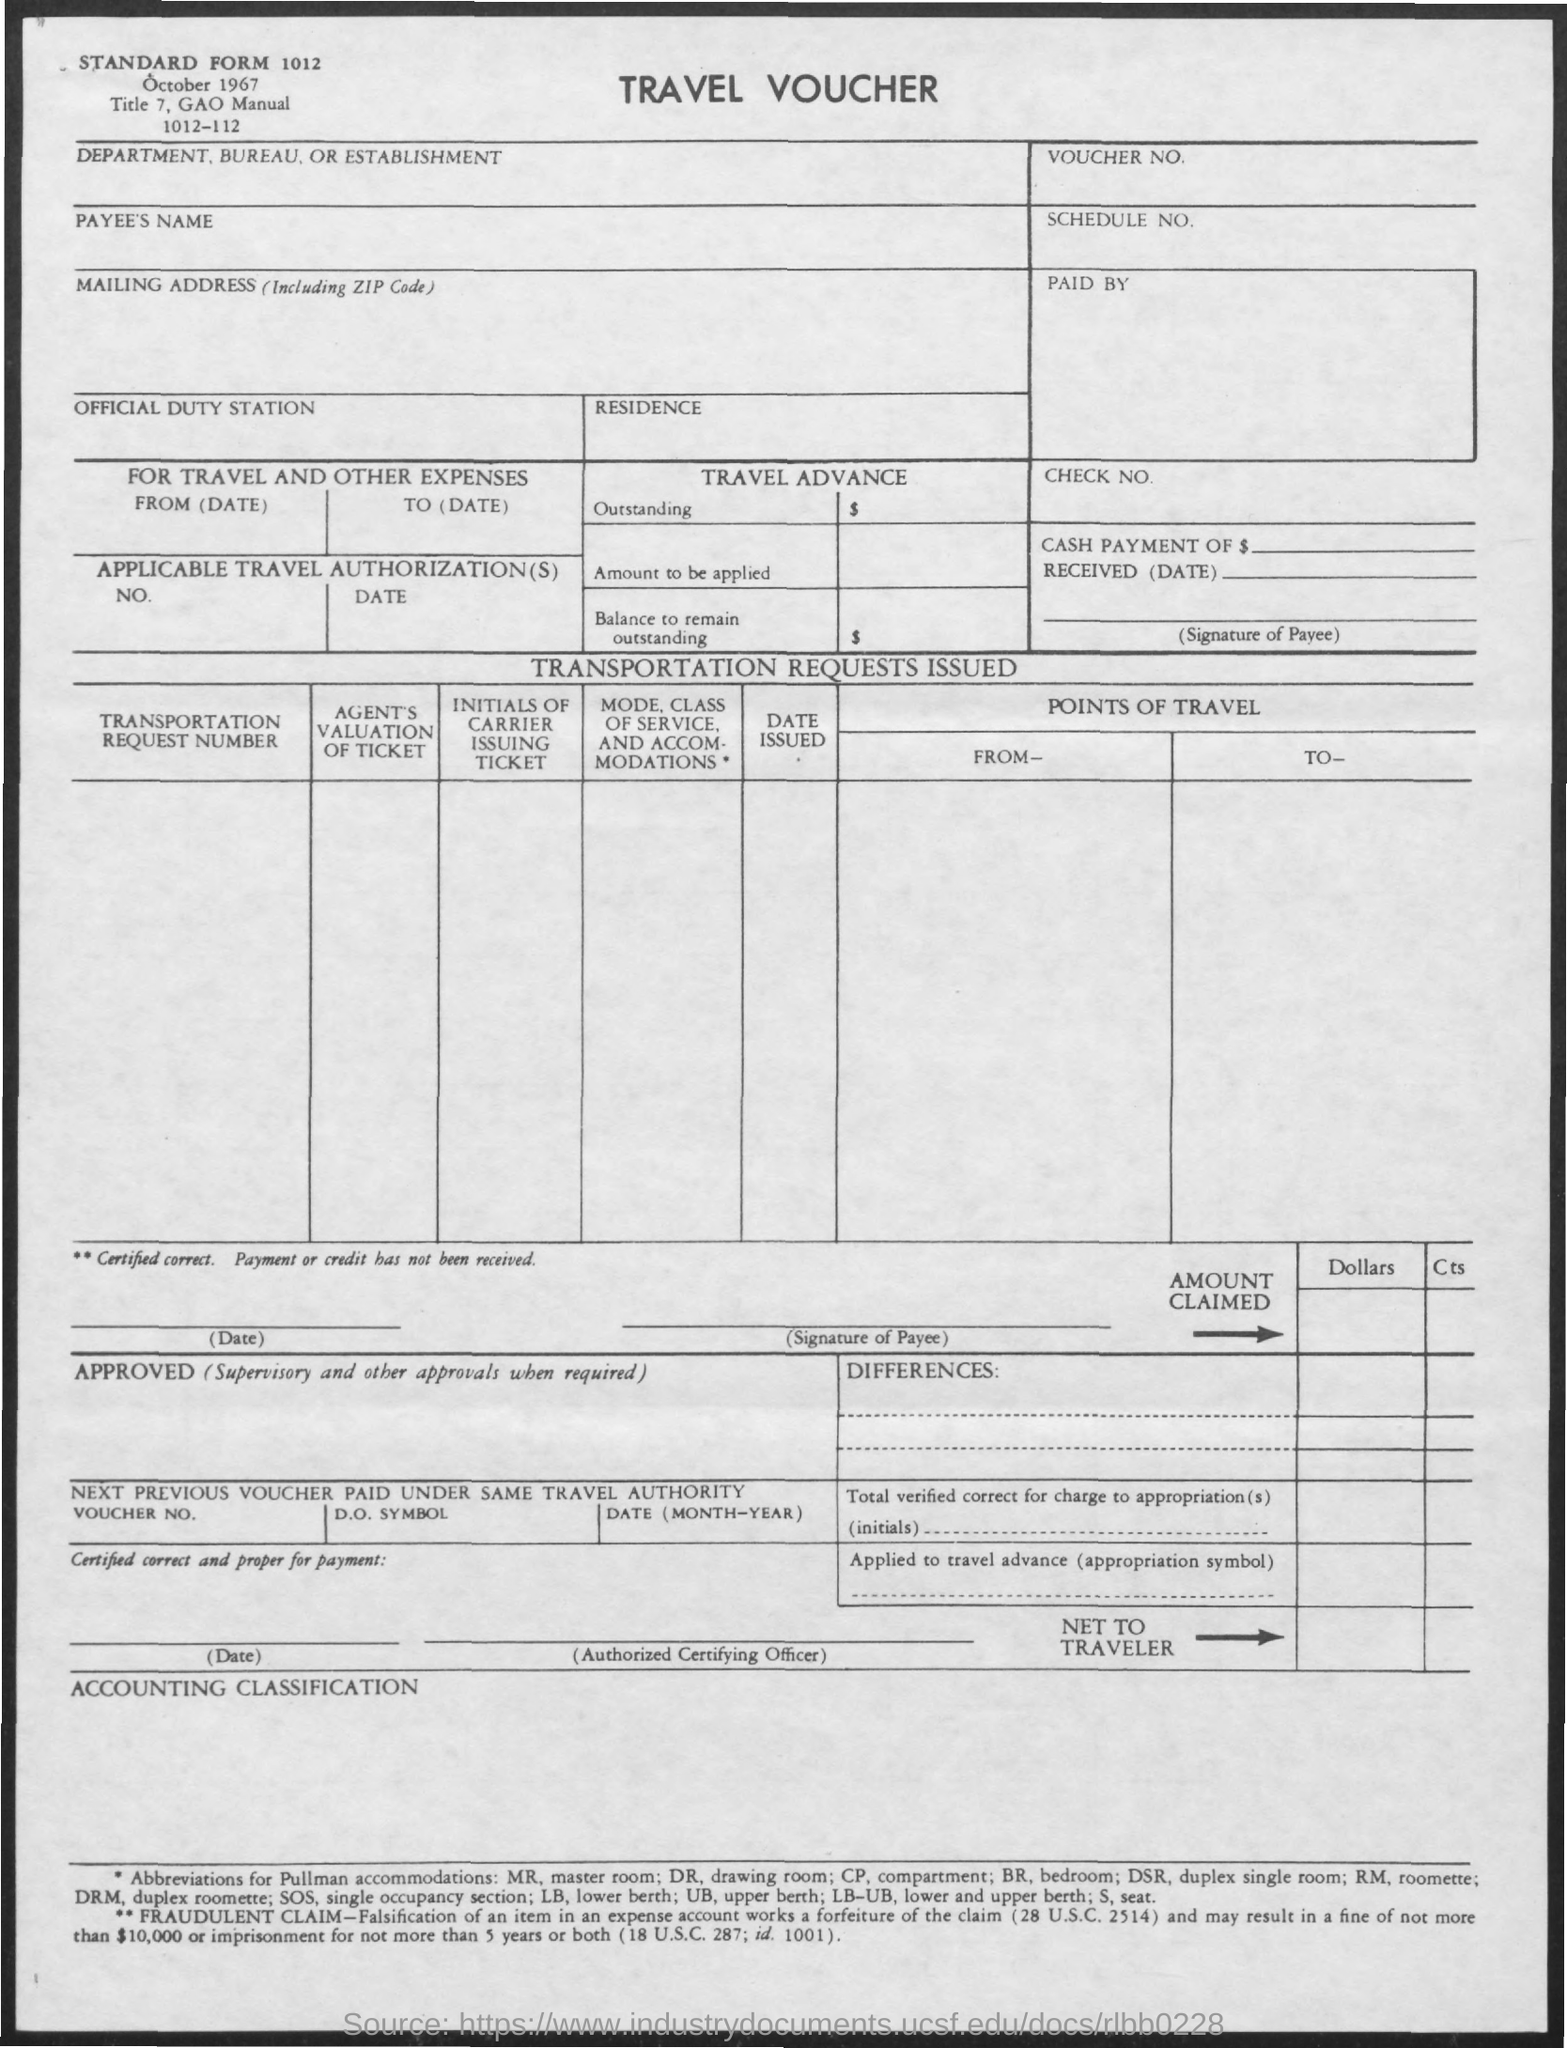What is the title of the document?
Keep it short and to the point. Travel Voucher. What is the date mentioned in the document?
Your answer should be compact. October 1967. 